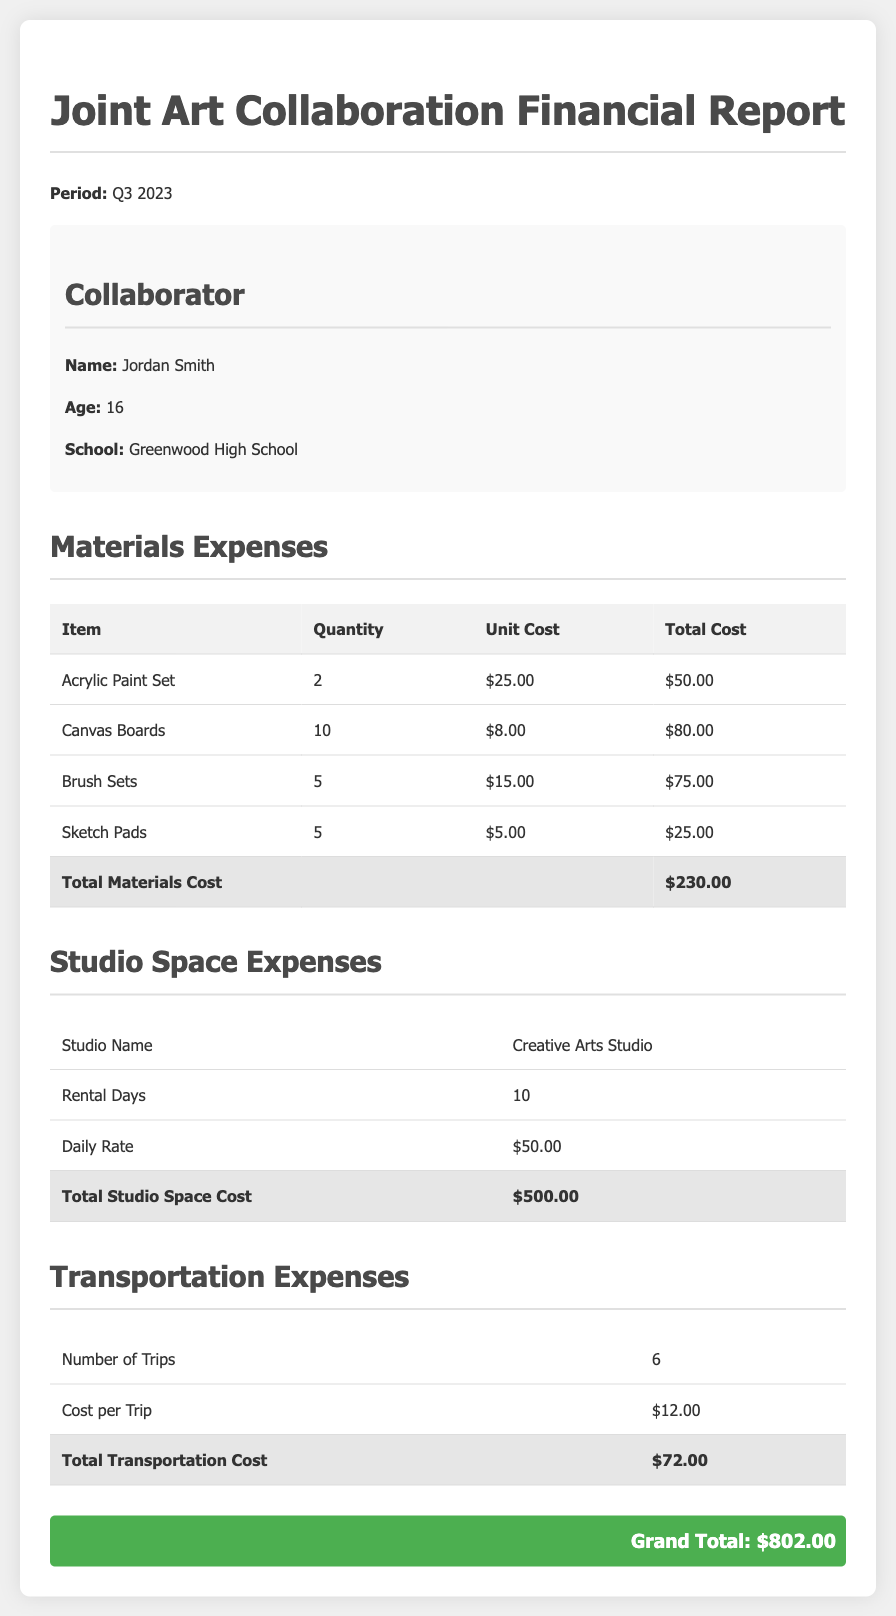What is the total materials cost? The total materials cost is listed in the materials expenses section of the document, which adds up to $230.00.
Answer: $230.00 How many acrylic paint sets were purchased? The document specifies that 2 acrylic paint sets were purchased under the materials expenses section.
Answer: 2 What is the daily rate for studio space? The daily rate for studio space is provided in the studio space expenses section as $50.00.
Answer: $50.00 How many trips were made for transportation? The number of trips for transportation is mentioned as 6 in the transportation expenses section.
Answer: 6 What is the grand total expense? The grand total expense is summarized at the end of the document, which equates to $802.00.
Answer: $802.00 What school does the collaborator attend? The collaborator's school is noted as Greenwood High School in the collaborator info section.
Answer: Greenwood High School How many canvas boards were purchased? The quantity of canvas boards purchased is detailed in the materials expenses section, which states 10 were bought.
Answer: 10 How much was spent on studio space rental? The document indicates that the total studio space rental cost is $500.00.
Answer: $500.00 What is the cost per trip for transportation? The cost per trip for transportation is shown in the transportation expenses section as $12.00.
Answer: $12.00 